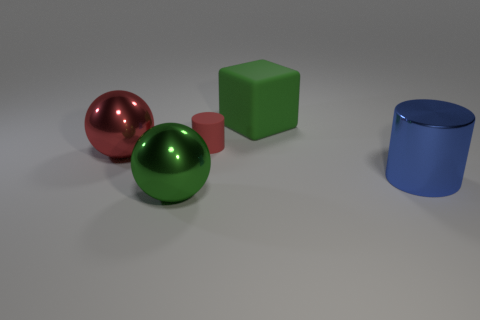Does the small matte cylinder have the same color as the metal thing in front of the blue shiny thing?
Ensure brevity in your answer.  No. Are there more green cubes than matte spheres?
Your answer should be very brief. Yes. Is there anything else that has the same color as the big shiny cylinder?
Offer a very short reply. No. What number of other things are there of the same size as the block?
Provide a succinct answer. 3. What material is the red ball that is to the left of the green thing behind the object that is on the right side of the large rubber thing?
Provide a succinct answer. Metal. Are the big green block and the sphere that is behind the big green metallic ball made of the same material?
Your response must be concise. No. Is the number of big cubes on the right side of the rubber block less than the number of green rubber things in front of the tiny rubber thing?
Keep it short and to the point. No. How many large red things are the same material as the large green cube?
Ensure brevity in your answer.  0. There is a metallic object right of the large sphere in front of the large red shiny sphere; is there a big blue metal cylinder that is right of it?
Offer a terse response. No. What number of cylinders are either big green things or tiny shiny objects?
Your answer should be very brief. 0. 